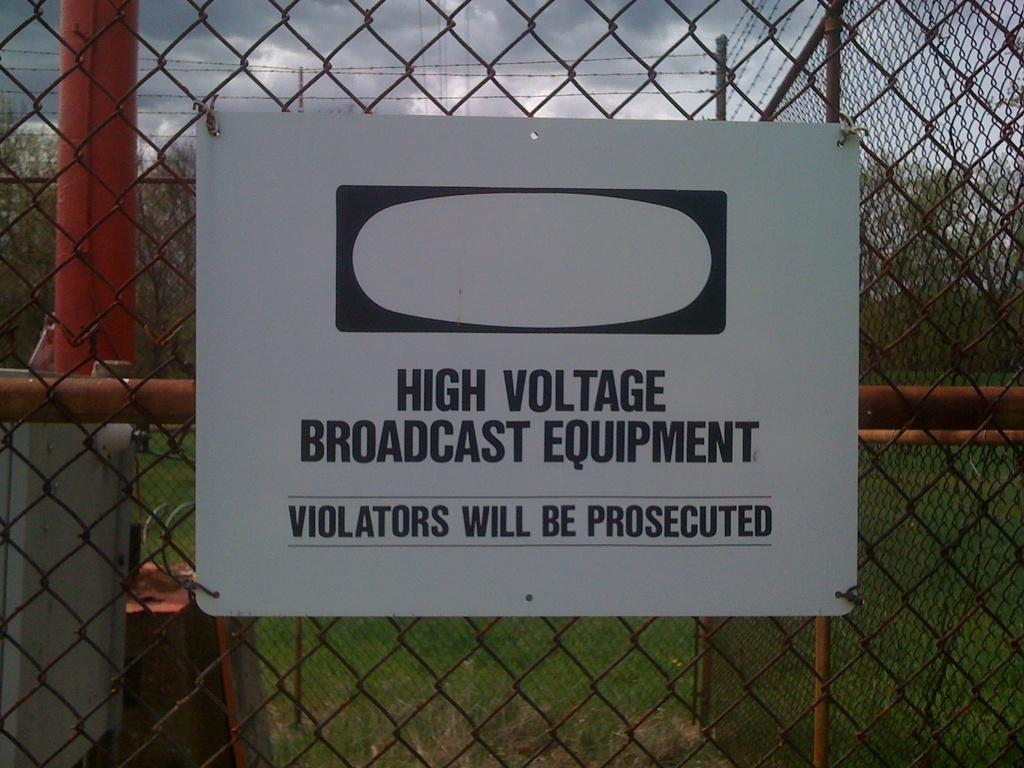What is the main structure in the image? There is a board attached to a mesh in the image. What can be seen in the background of the image? There are trees in the background of the image. What is the condition of the sky in the image? The sky is covered with clouds. What type of fruit is hanging from the mesh in the image? There is no fruit hanging from the mesh in the image. 